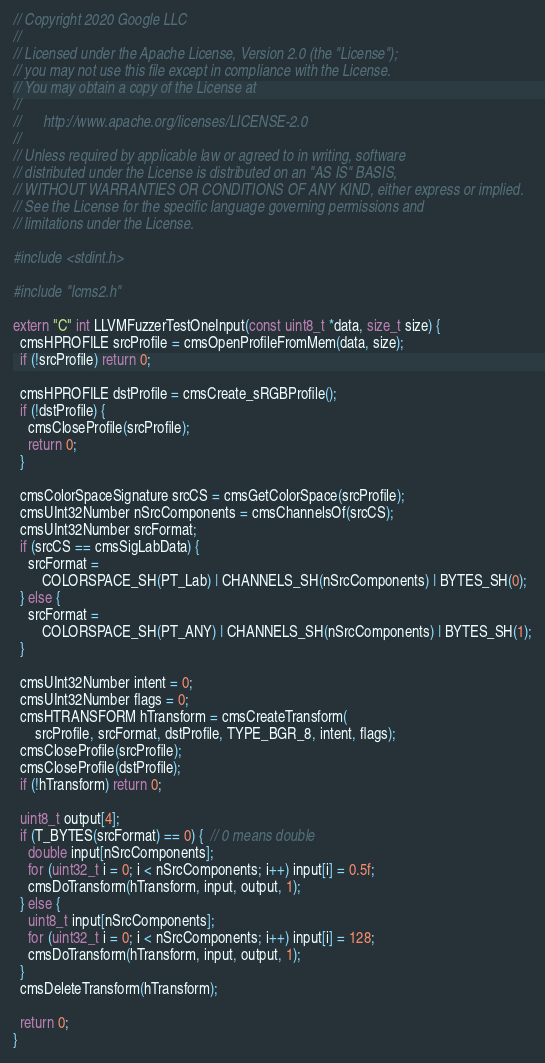Convert code to text. <code><loc_0><loc_0><loc_500><loc_500><_C++_>// Copyright 2020 Google LLC
//
// Licensed under the Apache License, Version 2.0 (the "License");
// you may not use this file except in compliance with the License.
// You may obtain a copy of the License at
//
//      http://www.apache.org/licenses/LICENSE-2.0
//
// Unless required by applicable law or agreed to in writing, software
// distributed under the License is distributed on an "AS IS" BASIS,
// WITHOUT WARRANTIES OR CONDITIONS OF ANY KIND, either express or implied.
// See the License for the specific language governing permissions and
// limitations under the License.

#include <stdint.h>

#include "lcms2.h"

extern "C" int LLVMFuzzerTestOneInput(const uint8_t *data, size_t size) {
  cmsHPROFILE srcProfile = cmsOpenProfileFromMem(data, size);
  if (!srcProfile) return 0;

  cmsHPROFILE dstProfile = cmsCreate_sRGBProfile();
  if (!dstProfile) {
    cmsCloseProfile(srcProfile);
    return 0;
  }

  cmsColorSpaceSignature srcCS = cmsGetColorSpace(srcProfile);
  cmsUInt32Number nSrcComponents = cmsChannelsOf(srcCS);
  cmsUInt32Number srcFormat;
  if (srcCS == cmsSigLabData) {
    srcFormat =
        COLORSPACE_SH(PT_Lab) | CHANNELS_SH(nSrcComponents) | BYTES_SH(0);
  } else {
    srcFormat =
        COLORSPACE_SH(PT_ANY) | CHANNELS_SH(nSrcComponents) | BYTES_SH(1);
  }

  cmsUInt32Number intent = 0;
  cmsUInt32Number flags = 0;
  cmsHTRANSFORM hTransform = cmsCreateTransform(
      srcProfile, srcFormat, dstProfile, TYPE_BGR_8, intent, flags);
  cmsCloseProfile(srcProfile);
  cmsCloseProfile(dstProfile);
  if (!hTransform) return 0;

  uint8_t output[4];
  if (T_BYTES(srcFormat) == 0) {  // 0 means double
    double input[nSrcComponents];
    for (uint32_t i = 0; i < nSrcComponents; i++) input[i] = 0.5f;
    cmsDoTransform(hTransform, input, output, 1);
  } else {
    uint8_t input[nSrcComponents];
    for (uint32_t i = 0; i < nSrcComponents; i++) input[i] = 128;
    cmsDoTransform(hTransform, input, output, 1);
  }
  cmsDeleteTransform(hTransform);

  return 0;
}
</code> 